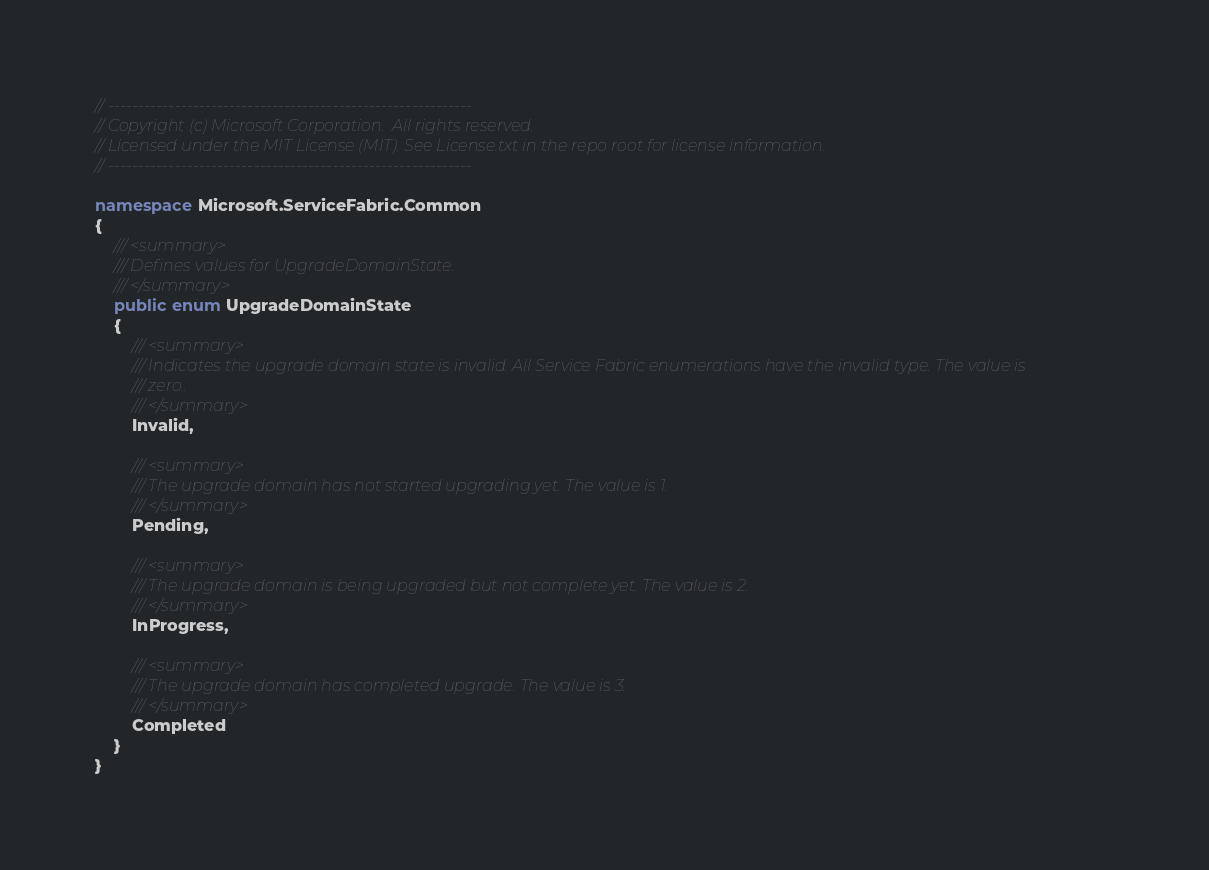<code> <loc_0><loc_0><loc_500><loc_500><_C#_>// ------------------------------------------------------------
// Copyright (c) Microsoft Corporation.  All rights reserved.
// Licensed under the MIT License (MIT). See License.txt in the repo root for license information.
// ------------------------------------------------------------

namespace Microsoft.ServiceFabric.Common
{
    /// <summary>
    /// Defines values for UpgradeDomainState.
    /// </summary>
    public enum UpgradeDomainState
    {
        /// <summary>
        /// Indicates the upgrade domain state is invalid. All Service Fabric enumerations have the invalid type. The value is
        /// zero..
        /// </summary>
        Invalid,

        /// <summary>
        /// The upgrade domain has not started upgrading yet. The value is 1.
        /// </summary>
        Pending,

        /// <summary>
        /// The upgrade domain is being upgraded but not complete yet. The value is 2.
        /// </summary>
        InProgress,

        /// <summary>
        /// The upgrade domain has completed upgrade. The value is 3.
        /// </summary>
        Completed
    }
}
</code> 